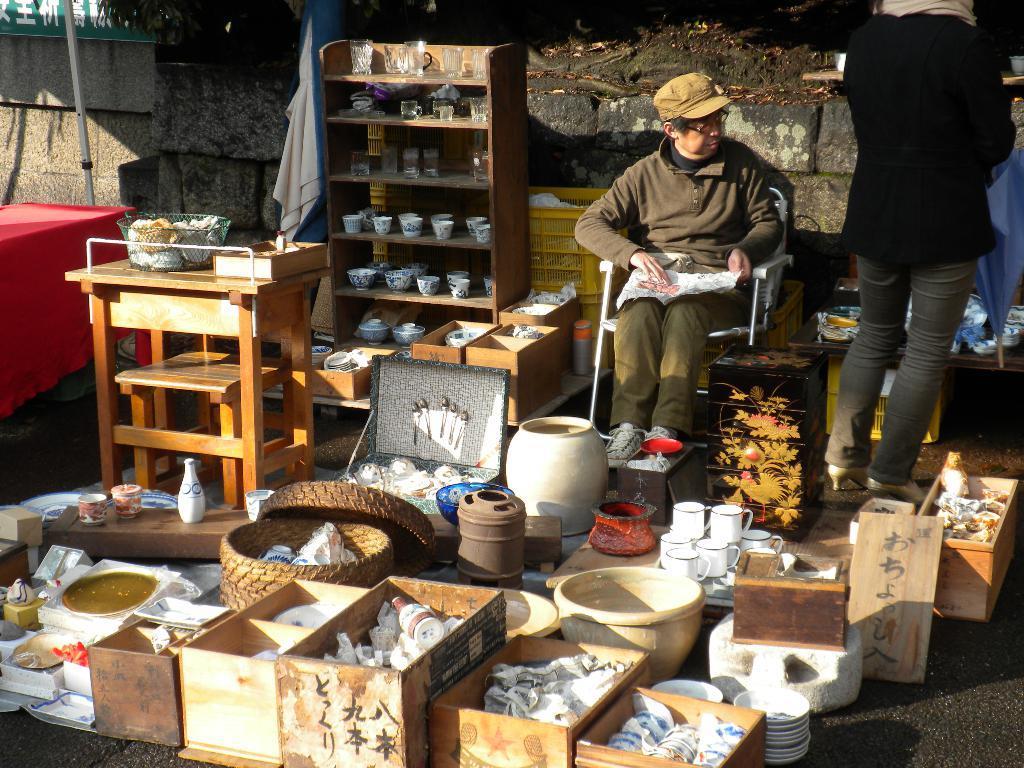How would you summarize this image in a sentence or two? In this picture we can see a person who is sitting on the chair. He wear a cap. Here we can see some boxes, baskets, cups, and plates. This is rack. And there is a wall. Here we can see a person who is standing on the road. 